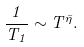<formula> <loc_0><loc_0><loc_500><loc_500>\frac { 1 } { T _ { 1 } } \sim T ^ { \bar { \eta } } .</formula> 